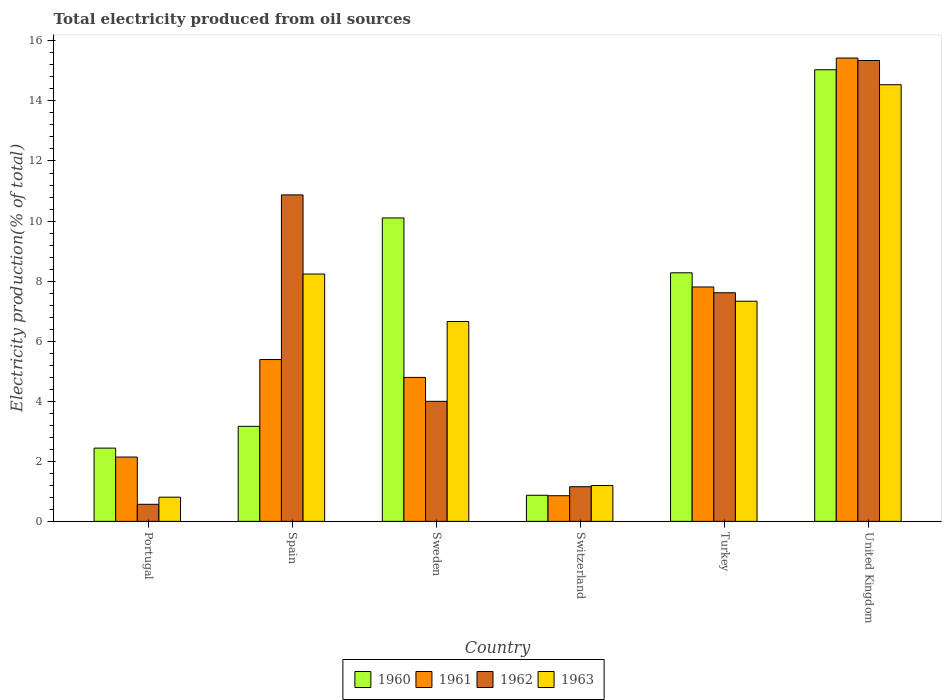How many groups of bars are there?
Offer a terse response. 6. How many bars are there on the 2nd tick from the left?
Offer a terse response. 4. What is the label of the 4th group of bars from the left?
Provide a short and direct response. Switzerland. What is the total electricity produced in 1963 in Turkey?
Provide a succinct answer. 7.33. Across all countries, what is the maximum total electricity produced in 1963?
Make the answer very short. 14.54. Across all countries, what is the minimum total electricity produced in 1960?
Ensure brevity in your answer.  0.87. In which country was the total electricity produced in 1961 maximum?
Your response must be concise. United Kingdom. In which country was the total electricity produced in 1961 minimum?
Make the answer very short. Switzerland. What is the total total electricity produced in 1962 in the graph?
Give a very brief answer. 39.55. What is the difference between the total electricity produced in 1961 in Portugal and that in Sweden?
Your response must be concise. -2.65. What is the difference between the total electricity produced in 1961 in Sweden and the total electricity produced in 1960 in Switzerland?
Your response must be concise. 3.92. What is the average total electricity produced in 1963 per country?
Provide a short and direct response. 6.46. What is the difference between the total electricity produced of/in 1960 and total electricity produced of/in 1963 in United Kingdom?
Ensure brevity in your answer.  0.5. What is the ratio of the total electricity produced in 1963 in Turkey to that in United Kingdom?
Offer a terse response. 0.5. Is the total electricity produced in 1963 in Spain less than that in Turkey?
Offer a very short reply. No. What is the difference between the highest and the second highest total electricity produced in 1962?
Your answer should be compact. 3.26. What is the difference between the highest and the lowest total electricity produced in 1961?
Provide a short and direct response. 14.57. Is it the case that in every country, the sum of the total electricity produced in 1963 and total electricity produced in 1962 is greater than the sum of total electricity produced in 1960 and total electricity produced in 1961?
Ensure brevity in your answer.  No. What does the 3rd bar from the right in Switzerland represents?
Make the answer very short. 1961. Is it the case that in every country, the sum of the total electricity produced in 1960 and total electricity produced in 1962 is greater than the total electricity produced in 1961?
Provide a short and direct response. Yes. How many bars are there?
Offer a terse response. 24. How many countries are there in the graph?
Your answer should be very brief. 6. What is the difference between two consecutive major ticks on the Y-axis?
Provide a short and direct response. 2. Are the values on the major ticks of Y-axis written in scientific E-notation?
Give a very brief answer. No. Does the graph contain any zero values?
Your answer should be very brief. No. Where does the legend appear in the graph?
Provide a succinct answer. Bottom center. How are the legend labels stacked?
Keep it short and to the point. Horizontal. What is the title of the graph?
Your response must be concise. Total electricity produced from oil sources. What is the label or title of the X-axis?
Provide a succinct answer. Country. What is the label or title of the Y-axis?
Your response must be concise. Electricity production(% of total). What is the Electricity production(% of total) of 1960 in Portugal?
Give a very brief answer. 2.44. What is the Electricity production(% of total) of 1961 in Portugal?
Provide a short and direct response. 2.14. What is the Electricity production(% of total) in 1962 in Portugal?
Give a very brief answer. 0.57. What is the Electricity production(% of total) in 1963 in Portugal?
Your answer should be compact. 0.81. What is the Electricity production(% of total) in 1960 in Spain?
Make the answer very short. 3.16. What is the Electricity production(% of total) in 1961 in Spain?
Your answer should be compact. 5.39. What is the Electricity production(% of total) of 1962 in Spain?
Give a very brief answer. 10.87. What is the Electricity production(% of total) in 1963 in Spain?
Give a very brief answer. 8.24. What is the Electricity production(% of total) of 1960 in Sweden?
Provide a succinct answer. 10.1. What is the Electricity production(% of total) of 1961 in Sweden?
Your response must be concise. 4.79. What is the Electricity production(% of total) of 1962 in Sweden?
Ensure brevity in your answer.  4. What is the Electricity production(% of total) in 1963 in Sweden?
Provide a succinct answer. 6.66. What is the Electricity production(% of total) in 1960 in Switzerland?
Give a very brief answer. 0.87. What is the Electricity production(% of total) of 1961 in Switzerland?
Give a very brief answer. 0.85. What is the Electricity production(% of total) of 1962 in Switzerland?
Give a very brief answer. 1.15. What is the Electricity production(% of total) of 1963 in Switzerland?
Your response must be concise. 1.19. What is the Electricity production(% of total) in 1960 in Turkey?
Your answer should be compact. 8.28. What is the Electricity production(% of total) of 1961 in Turkey?
Ensure brevity in your answer.  7.8. What is the Electricity production(% of total) of 1962 in Turkey?
Give a very brief answer. 7.61. What is the Electricity production(% of total) of 1963 in Turkey?
Offer a terse response. 7.33. What is the Electricity production(% of total) in 1960 in United Kingdom?
Your answer should be very brief. 15.04. What is the Electricity production(% of total) of 1961 in United Kingdom?
Provide a succinct answer. 15.43. What is the Electricity production(% of total) in 1962 in United Kingdom?
Provide a succinct answer. 15.35. What is the Electricity production(% of total) of 1963 in United Kingdom?
Provide a succinct answer. 14.54. Across all countries, what is the maximum Electricity production(% of total) of 1960?
Provide a short and direct response. 15.04. Across all countries, what is the maximum Electricity production(% of total) in 1961?
Provide a short and direct response. 15.43. Across all countries, what is the maximum Electricity production(% of total) in 1962?
Your answer should be compact. 15.35. Across all countries, what is the maximum Electricity production(% of total) in 1963?
Ensure brevity in your answer.  14.54. Across all countries, what is the minimum Electricity production(% of total) in 1960?
Provide a short and direct response. 0.87. Across all countries, what is the minimum Electricity production(% of total) of 1961?
Your answer should be very brief. 0.85. Across all countries, what is the minimum Electricity production(% of total) in 1962?
Your response must be concise. 0.57. Across all countries, what is the minimum Electricity production(% of total) in 1963?
Provide a short and direct response. 0.81. What is the total Electricity production(% of total) of 1960 in the graph?
Ensure brevity in your answer.  39.89. What is the total Electricity production(% of total) of 1961 in the graph?
Give a very brief answer. 36.41. What is the total Electricity production(% of total) of 1962 in the graph?
Offer a very short reply. 39.55. What is the total Electricity production(% of total) of 1963 in the graph?
Give a very brief answer. 38.76. What is the difference between the Electricity production(% of total) of 1960 in Portugal and that in Spain?
Ensure brevity in your answer.  -0.72. What is the difference between the Electricity production(% of total) in 1961 in Portugal and that in Spain?
Offer a terse response. -3.25. What is the difference between the Electricity production(% of total) in 1962 in Portugal and that in Spain?
Provide a succinct answer. -10.3. What is the difference between the Electricity production(% of total) in 1963 in Portugal and that in Spain?
Your answer should be compact. -7.43. What is the difference between the Electricity production(% of total) in 1960 in Portugal and that in Sweden?
Your response must be concise. -7.66. What is the difference between the Electricity production(% of total) of 1961 in Portugal and that in Sweden?
Ensure brevity in your answer.  -2.65. What is the difference between the Electricity production(% of total) in 1962 in Portugal and that in Sweden?
Your answer should be very brief. -3.43. What is the difference between the Electricity production(% of total) in 1963 in Portugal and that in Sweden?
Your answer should be very brief. -5.85. What is the difference between the Electricity production(% of total) of 1960 in Portugal and that in Switzerland?
Your answer should be very brief. 1.57. What is the difference between the Electricity production(% of total) in 1961 in Portugal and that in Switzerland?
Your response must be concise. 1.29. What is the difference between the Electricity production(% of total) in 1962 in Portugal and that in Switzerland?
Your response must be concise. -0.59. What is the difference between the Electricity production(% of total) of 1963 in Portugal and that in Switzerland?
Your answer should be very brief. -0.39. What is the difference between the Electricity production(% of total) in 1960 in Portugal and that in Turkey?
Keep it short and to the point. -5.84. What is the difference between the Electricity production(% of total) in 1961 in Portugal and that in Turkey?
Keep it short and to the point. -5.66. What is the difference between the Electricity production(% of total) of 1962 in Portugal and that in Turkey?
Give a very brief answer. -7.04. What is the difference between the Electricity production(% of total) in 1963 in Portugal and that in Turkey?
Provide a succinct answer. -6.53. What is the difference between the Electricity production(% of total) of 1960 in Portugal and that in United Kingdom?
Offer a very short reply. -12.6. What is the difference between the Electricity production(% of total) in 1961 in Portugal and that in United Kingdom?
Provide a short and direct response. -13.29. What is the difference between the Electricity production(% of total) of 1962 in Portugal and that in United Kingdom?
Ensure brevity in your answer.  -14.78. What is the difference between the Electricity production(% of total) of 1963 in Portugal and that in United Kingdom?
Keep it short and to the point. -13.74. What is the difference between the Electricity production(% of total) in 1960 in Spain and that in Sweden?
Ensure brevity in your answer.  -6.94. What is the difference between the Electricity production(% of total) of 1961 in Spain and that in Sweden?
Your answer should be very brief. 0.6. What is the difference between the Electricity production(% of total) in 1962 in Spain and that in Sweden?
Provide a short and direct response. 6.87. What is the difference between the Electricity production(% of total) in 1963 in Spain and that in Sweden?
Your response must be concise. 1.58. What is the difference between the Electricity production(% of total) of 1960 in Spain and that in Switzerland?
Your response must be concise. 2.29. What is the difference between the Electricity production(% of total) of 1961 in Spain and that in Switzerland?
Give a very brief answer. 4.53. What is the difference between the Electricity production(% of total) of 1962 in Spain and that in Switzerland?
Your answer should be compact. 9.72. What is the difference between the Electricity production(% of total) of 1963 in Spain and that in Switzerland?
Your answer should be compact. 7.04. What is the difference between the Electricity production(% of total) of 1960 in Spain and that in Turkey?
Provide a short and direct response. -5.11. What is the difference between the Electricity production(% of total) of 1961 in Spain and that in Turkey?
Offer a terse response. -2.42. What is the difference between the Electricity production(% of total) in 1962 in Spain and that in Turkey?
Your answer should be very brief. 3.26. What is the difference between the Electricity production(% of total) of 1963 in Spain and that in Turkey?
Give a very brief answer. 0.91. What is the difference between the Electricity production(% of total) of 1960 in Spain and that in United Kingdom?
Keep it short and to the point. -11.87. What is the difference between the Electricity production(% of total) in 1961 in Spain and that in United Kingdom?
Provide a short and direct response. -10.04. What is the difference between the Electricity production(% of total) of 1962 in Spain and that in United Kingdom?
Provide a succinct answer. -4.48. What is the difference between the Electricity production(% of total) of 1963 in Spain and that in United Kingdom?
Your answer should be compact. -6.3. What is the difference between the Electricity production(% of total) in 1960 in Sweden and that in Switzerland?
Your answer should be compact. 9.23. What is the difference between the Electricity production(% of total) of 1961 in Sweden and that in Switzerland?
Ensure brevity in your answer.  3.94. What is the difference between the Electricity production(% of total) in 1962 in Sweden and that in Switzerland?
Offer a terse response. 2.84. What is the difference between the Electricity production(% of total) of 1963 in Sweden and that in Switzerland?
Give a very brief answer. 5.46. What is the difference between the Electricity production(% of total) in 1960 in Sweden and that in Turkey?
Give a very brief answer. 1.83. What is the difference between the Electricity production(% of total) in 1961 in Sweden and that in Turkey?
Make the answer very short. -3.01. What is the difference between the Electricity production(% of total) in 1962 in Sweden and that in Turkey?
Ensure brevity in your answer.  -3.61. What is the difference between the Electricity production(% of total) of 1963 in Sweden and that in Turkey?
Provide a short and direct response. -0.68. What is the difference between the Electricity production(% of total) of 1960 in Sweden and that in United Kingdom?
Offer a terse response. -4.93. What is the difference between the Electricity production(% of total) of 1961 in Sweden and that in United Kingdom?
Your answer should be very brief. -10.64. What is the difference between the Electricity production(% of total) in 1962 in Sweden and that in United Kingdom?
Your answer should be very brief. -11.35. What is the difference between the Electricity production(% of total) in 1963 in Sweden and that in United Kingdom?
Make the answer very short. -7.89. What is the difference between the Electricity production(% of total) of 1960 in Switzerland and that in Turkey?
Offer a terse response. -7.41. What is the difference between the Electricity production(% of total) in 1961 in Switzerland and that in Turkey?
Give a very brief answer. -6.95. What is the difference between the Electricity production(% of total) in 1962 in Switzerland and that in Turkey?
Make the answer very short. -6.46. What is the difference between the Electricity production(% of total) of 1963 in Switzerland and that in Turkey?
Your response must be concise. -6.14. What is the difference between the Electricity production(% of total) of 1960 in Switzerland and that in United Kingdom?
Offer a very short reply. -14.17. What is the difference between the Electricity production(% of total) in 1961 in Switzerland and that in United Kingdom?
Offer a terse response. -14.57. What is the difference between the Electricity production(% of total) of 1962 in Switzerland and that in United Kingdom?
Offer a very short reply. -14.19. What is the difference between the Electricity production(% of total) of 1963 in Switzerland and that in United Kingdom?
Your answer should be compact. -13.35. What is the difference between the Electricity production(% of total) in 1960 in Turkey and that in United Kingdom?
Your response must be concise. -6.76. What is the difference between the Electricity production(% of total) of 1961 in Turkey and that in United Kingdom?
Provide a succinct answer. -7.62. What is the difference between the Electricity production(% of total) in 1962 in Turkey and that in United Kingdom?
Offer a terse response. -7.73. What is the difference between the Electricity production(% of total) of 1963 in Turkey and that in United Kingdom?
Give a very brief answer. -7.21. What is the difference between the Electricity production(% of total) in 1960 in Portugal and the Electricity production(% of total) in 1961 in Spain?
Offer a terse response. -2.95. What is the difference between the Electricity production(% of total) in 1960 in Portugal and the Electricity production(% of total) in 1962 in Spain?
Keep it short and to the point. -8.43. What is the difference between the Electricity production(% of total) in 1960 in Portugal and the Electricity production(% of total) in 1963 in Spain?
Provide a succinct answer. -5.8. What is the difference between the Electricity production(% of total) in 1961 in Portugal and the Electricity production(% of total) in 1962 in Spain?
Make the answer very short. -8.73. What is the difference between the Electricity production(% of total) of 1961 in Portugal and the Electricity production(% of total) of 1963 in Spain?
Provide a short and direct response. -6.09. What is the difference between the Electricity production(% of total) in 1962 in Portugal and the Electricity production(% of total) in 1963 in Spain?
Provide a succinct answer. -7.67. What is the difference between the Electricity production(% of total) in 1960 in Portugal and the Electricity production(% of total) in 1961 in Sweden?
Keep it short and to the point. -2.35. What is the difference between the Electricity production(% of total) in 1960 in Portugal and the Electricity production(% of total) in 1962 in Sweden?
Your answer should be very brief. -1.56. What is the difference between the Electricity production(% of total) of 1960 in Portugal and the Electricity production(% of total) of 1963 in Sweden?
Keep it short and to the point. -4.22. What is the difference between the Electricity production(% of total) of 1961 in Portugal and the Electricity production(% of total) of 1962 in Sweden?
Provide a succinct answer. -1.86. What is the difference between the Electricity production(% of total) in 1961 in Portugal and the Electricity production(% of total) in 1963 in Sweden?
Offer a terse response. -4.51. What is the difference between the Electricity production(% of total) of 1962 in Portugal and the Electricity production(% of total) of 1963 in Sweden?
Your answer should be very brief. -6.09. What is the difference between the Electricity production(% of total) of 1960 in Portugal and the Electricity production(% of total) of 1961 in Switzerland?
Your answer should be compact. 1.59. What is the difference between the Electricity production(% of total) of 1960 in Portugal and the Electricity production(% of total) of 1962 in Switzerland?
Provide a succinct answer. 1.29. What is the difference between the Electricity production(% of total) of 1960 in Portugal and the Electricity production(% of total) of 1963 in Switzerland?
Your answer should be very brief. 1.25. What is the difference between the Electricity production(% of total) of 1961 in Portugal and the Electricity production(% of total) of 1962 in Switzerland?
Your response must be concise. 0.99. What is the difference between the Electricity production(% of total) of 1961 in Portugal and the Electricity production(% of total) of 1963 in Switzerland?
Keep it short and to the point. 0.95. What is the difference between the Electricity production(% of total) in 1962 in Portugal and the Electricity production(% of total) in 1963 in Switzerland?
Your answer should be very brief. -0.63. What is the difference between the Electricity production(% of total) in 1960 in Portugal and the Electricity production(% of total) in 1961 in Turkey?
Your answer should be very brief. -5.36. What is the difference between the Electricity production(% of total) in 1960 in Portugal and the Electricity production(% of total) in 1962 in Turkey?
Your answer should be very brief. -5.17. What is the difference between the Electricity production(% of total) of 1960 in Portugal and the Electricity production(% of total) of 1963 in Turkey?
Keep it short and to the point. -4.89. What is the difference between the Electricity production(% of total) of 1961 in Portugal and the Electricity production(% of total) of 1962 in Turkey?
Offer a terse response. -5.47. What is the difference between the Electricity production(% of total) in 1961 in Portugal and the Electricity production(% of total) in 1963 in Turkey?
Give a very brief answer. -5.19. What is the difference between the Electricity production(% of total) in 1962 in Portugal and the Electricity production(% of total) in 1963 in Turkey?
Your response must be concise. -6.76. What is the difference between the Electricity production(% of total) in 1960 in Portugal and the Electricity production(% of total) in 1961 in United Kingdom?
Provide a succinct answer. -12.99. What is the difference between the Electricity production(% of total) in 1960 in Portugal and the Electricity production(% of total) in 1962 in United Kingdom?
Your answer should be compact. -12.91. What is the difference between the Electricity production(% of total) of 1960 in Portugal and the Electricity production(% of total) of 1963 in United Kingdom?
Make the answer very short. -12.1. What is the difference between the Electricity production(% of total) in 1961 in Portugal and the Electricity production(% of total) in 1962 in United Kingdom?
Your answer should be very brief. -13.2. What is the difference between the Electricity production(% of total) in 1961 in Portugal and the Electricity production(% of total) in 1963 in United Kingdom?
Give a very brief answer. -12.4. What is the difference between the Electricity production(% of total) in 1962 in Portugal and the Electricity production(% of total) in 1963 in United Kingdom?
Make the answer very short. -13.97. What is the difference between the Electricity production(% of total) in 1960 in Spain and the Electricity production(% of total) in 1961 in Sweden?
Provide a short and direct response. -1.63. What is the difference between the Electricity production(% of total) in 1960 in Spain and the Electricity production(% of total) in 1963 in Sweden?
Keep it short and to the point. -3.49. What is the difference between the Electricity production(% of total) in 1961 in Spain and the Electricity production(% of total) in 1962 in Sweden?
Your answer should be very brief. 1.39. What is the difference between the Electricity production(% of total) of 1961 in Spain and the Electricity production(% of total) of 1963 in Sweden?
Your answer should be compact. -1.27. What is the difference between the Electricity production(% of total) of 1962 in Spain and the Electricity production(% of total) of 1963 in Sweden?
Make the answer very short. 4.22. What is the difference between the Electricity production(% of total) of 1960 in Spain and the Electricity production(% of total) of 1961 in Switzerland?
Offer a very short reply. 2.31. What is the difference between the Electricity production(% of total) of 1960 in Spain and the Electricity production(% of total) of 1962 in Switzerland?
Ensure brevity in your answer.  2.01. What is the difference between the Electricity production(% of total) in 1960 in Spain and the Electricity production(% of total) in 1963 in Switzerland?
Make the answer very short. 1.97. What is the difference between the Electricity production(% of total) of 1961 in Spain and the Electricity production(% of total) of 1962 in Switzerland?
Provide a short and direct response. 4.24. What is the difference between the Electricity production(% of total) in 1961 in Spain and the Electricity production(% of total) in 1963 in Switzerland?
Provide a succinct answer. 4.2. What is the difference between the Electricity production(% of total) in 1962 in Spain and the Electricity production(% of total) in 1963 in Switzerland?
Give a very brief answer. 9.68. What is the difference between the Electricity production(% of total) of 1960 in Spain and the Electricity production(% of total) of 1961 in Turkey?
Your answer should be compact. -4.64. What is the difference between the Electricity production(% of total) of 1960 in Spain and the Electricity production(% of total) of 1962 in Turkey?
Provide a succinct answer. -4.45. What is the difference between the Electricity production(% of total) in 1960 in Spain and the Electricity production(% of total) in 1963 in Turkey?
Offer a terse response. -4.17. What is the difference between the Electricity production(% of total) in 1961 in Spain and the Electricity production(% of total) in 1962 in Turkey?
Provide a succinct answer. -2.22. What is the difference between the Electricity production(% of total) in 1961 in Spain and the Electricity production(% of total) in 1963 in Turkey?
Provide a succinct answer. -1.94. What is the difference between the Electricity production(% of total) of 1962 in Spain and the Electricity production(% of total) of 1963 in Turkey?
Make the answer very short. 3.54. What is the difference between the Electricity production(% of total) in 1960 in Spain and the Electricity production(% of total) in 1961 in United Kingdom?
Give a very brief answer. -12.26. What is the difference between the Electricity production(% of total) in 1960 in Spain and the Electricity production(% of total) in 1962 in United Kingdom?
Offer a terse response. -12.18. What is the difference between the Electricity production(% of total) in 1960 in Spain and the Electricity production(% of total) in 1963 in United Kingdom?
Provide a short and direct response. -11.38. What is the difference between the Electricity production(% of total) of 1961 in Spain and the Electricity production(% of total) of 1962 in United Kingdom?
Provide a short and direct response. -9.96. What is the difference between the Electricity production(% of total) in 1961 in Spain and the Electricity production(% of total) in 1963 in United Kingdom?
Provide a succinct answer. -9.15. What is the difference between the Electricity production(% of total) of 1962 in Spain and the Electricity production(% of total) of 1963 in United Kingdom?
Offer a very short reply. -3.67. What is the difference between the Electricity production(% of total) of 1960 in Sweden and the Electricity production(% of total) of 1961 in Switzerland?
Offer a very short reply. 9.25. What is the difference between the Electricity production(% of total) of 1960 in Sweden and the Electricity production(% of total) of 1962 in Switzerland?
Your answer should be compact. 8.95. What is the difference between the Electricity production(% of total) of 1960 in Sweden and the Electricity production(% of total) of 1963 in Switzerland?
Your answer should be compact. 8.91. What is the difference between the Electricity production(% of total) in 1961 in Sweden and the Electricity production(% of total) in 1962 in Switzerland?
Provide a succinct answer. 3.64. What is the difference between the Electricity production(% of total) in 1961 in Sweden and the Electricity production(% of total) in 1963 in Switzerland?
Provide a succinct answer. 3.6. What is the difference between the Electricity production(% of total) in 1962 in Sweden and the Electricity production(% of total) in 1963 in Switzerland?
Provide a succinct answer. 2.8. What is the difference between the Electricity production(% of total) of 1960 in Sweden and the Electricity production(% of total) of 1961 in Turkey?
Ensure brevity in your answer.  2.3. What is the difference between the Electricity production(% of total) of 1960 in Sweden and the Electricity production(% of total) of 1962 in Turkey?
Ensure brevity in your answer.  2.49. What is the difference between the Electricity production(% of total) in 1960 in Sweden and the Electricity production(% of total) in 1963 in Turkey?
Make the answer very short. 2.77. What is the difference between the Electricity production(% of total) in 1961 in Sweden and the Electricity production(% of total) in 1962 in Turkey?
Offer a terse response. -2.82. What is the difference between the Electricity production(% of total) of 1961 in Sweden and the Electricity production(% of total) of 1963 in Turkey?
Your answer should be very brief. -2.54. What is the difference between the Electricity production(% of total) of 1962 in Sweden and the Electricity production(% of total) of 1963 in Turkey?
Give a very brief answer. -3.33. What is the difference between the Electricity production(% of total) in 1960 in Sweden and the Electricity production(% of total) in 1961 in United Kingdom?
Your response must be concise. -5.32. What is the difference between the Electricity production(% of total) in 1960 in Sweden and the Electricity production(% of total) in 1962 in United Kingdom?
Provide a short and direct response. -5.24. What is the difference between the Electricity production(% of total) of 1960 in Sweden and the Electricity production(% of total) of 1963 in United Kingdom?
Offer a terse response. -4.44. What is the difference between the Electricity production(% of total) of 1961 in Sweden and the Electricity production(% of total) of 1962 in United Kingdom?
Keep it short and to the point. -10.55. What is the difference between the Electricity production(% of total) of 1961 in Sweden and the Electricity production(% of total) of 1963 in United Kingdom?
Provide a short and direct response. -9.75. What is the difference between the Electricity production(% of total) of 1962 in Sweden and the Electricity production(% of total) of 1963 in United Kingdom?
Provide a succinct answer. -10.54. What is the difference between the Electricity production(% of total) in 1960 in Switzerland and the Electricity production(% of total) in 1961 in Turkey?
Provide a succinct answer. -6.94. What is the difference between the Electricity production(% of total) of 1960 in Switzerland and the Electricity production(% of total) of 1962 in Turkey?
Your response must be concise. -6.74. What is the difference between the Electricity production(% of total) in 1960 in Switzerland and the Electricity production(% of total) in 1963 in Turkey?
Offer a terse response. -6.46. What is the difference between the Electricity production(% of total) in 1961 in Switzerland and the Electricity production(% of total) in 1962 in Turkey?
Give a very brief answer. -6.76. What is the difference between the Electricity production(% of total) in 1961 in Switzerland and the Electricity production(% of total) in 1963 in Turkey?
Offer a terse response. -6.48. What is the difference between the Electricity production(% of total) of 1962 in Switzerland and the Electricity production(% of total) of 1963 in Turkey?
Your response must be concise. -6.18. What is the difference between the Electricity production(% of total) in 1960 in Switzerland and the Electricity production(% of total) in 1961 in United Kingdom?
Ensure brevity in your answer.  -14.56. What is the difference between the Electricity production(% of total) in 1960 in Switzerland and the Electricity production(% of total) in 1962 in United Kingdom?
Your answer should be compact. -14.48. What is the difference between the Electricity production(% of total) of 1960 in Switzerland and the Electricity production(% of total) of 1963 in United Kingdom?
Provide a succinct answer. -13.67. What is the difference between the Electricity production(% of total) of 1961 in Switzerland and the Electricity production(% of total) of 1962 in United Kingdom?
Keep it short and to the point. -14.49. What is the difference between the Electricity production(% of total) in 1961 in Switzerland and the Electricity production(% of total) in 1963 in United Kingdom?
Give a very brief answer. -13.69. What is the difference between the Electricity production(% of total) in 1962 in Switzerland and the Electricity production(% of total) in 1963 in United Kingdom?
Your answer should be very brief. -13.39. What is the difference between the Electricity production(% of total) of 1960 in Turkey and the Electricity production(% of total) of 1961 in United Kingdom?
Your response must be concise. -7.15. What is the difference between the Electricity production(% of total) of 1960 in Turkey and the Electricity production(% of total) of 1962 in United Kingdom?
Keep it short and to the point. -7.07. What is the difference between the Electricity production(% of total) in 1960 in Turkey and the Electricity production(% of total) in 1963 in United Kingdom?
Your response must be concise. -6.26. What is the difference between the Electricity production(% of total) in 1961 in Turkey and the Electricity production(% of total) in 1962 in United Kingdom?
Your response must be concise. -7.54. What is the difference between the Electricity production(% of total) of 1961 in Turkey and the Electricity production(% of total) of 1963 in United Kingdom?
Make the answer very short. -6.74. What is the difference between the Electricity production(% of total) of 1962 in Turkey and the Electricity production(% of total) of 1963 in United Kingdom?
Your answer should be compact. -6.93. What is the average Electricity production(% of total) of 1960 per country?
Give a very brief answer. 6.65. What is the average Electricity production(% of total) in 1961 per country?
Your answer should be very brief. 6.07. What is the average Electricity production(% of total) in 1962 per country?
Your answer should be very brief. 6.59. What is the average Electricity production(% of total) of 1963 per country?
Offer a very short reply. 6.46. What is the difference between the Electricity production(% of total) in 1960 and Electricity production(% of total) in 1961 in Portugal?
Make the answer very short. 0.3. What is the difference between the Electricity production(% of total) of 1960 and Electricity production(% of total) of 1962 in Portugal?
Give a very brief answer. 1.87. What is the difference between the Electricity production(% of total) in 1960 and Electricity production(% of total) in 1963 in Portugal?
Offer a very short reply. 1.63. What is the difference between the Electricity production(% of total) of 1961 and Electricity production(% of total) of 1962 in Portugal?
Keep it short and to the point. 1.57. What is the difference between the Electricity production(% of total) in 1961 and Electricity production(% of total) in 1963 in Portugal?
Your response must be concise. 1.34. What is the difference between the Electricity production(% of total) of 1962 and Electricity production(% of total) of 1963 in Portugal?
Keep it short and to the point. -0.24. What is the difference between the Electricity production(% of total) in 1960 and Electricity production(% of total) in 1961 in Spain?
Your response must be concise. -2.22. What is the difference between the Electricity production(% of total) in 1960 and Electricity production(% of total) in 1962 in Spain?
Provide a short and direct response. -7.71. What is the difference between the Electricity production(% of total) in 1960 and Electricity production(% of total) in 1963 in Spain?
Your answer should be very brief. -5.07. What is the difference between the Electricity production(% of total) of 1961 and Electricity production(% of total) of 1962 in Spain?
Ensure brevity in your answer.  -5.48. What is the difference between the Electricity production(% of total) in 1961 and Electricity production(% of total) in 1963 in Spain?
Offer a very short reply. -2.85. What is the difference between the Electricity production(% of total) of 1962 and Electricity production(% of total) of 1963 in Spain?
Your answer should be very brief. 2.63. What is the difference between the Electricity production(% of total) in 1960 and Electricity production(% of total) in 1961 in Sweden?
Offer a terse response. 5.31. What is the difference between the Electricity production(% of total) of 1960 and Electricity production(% of total) of 1962 in Sweden?
Offer a very short reply. 6.11. What is the difference between the Electricity production(% of total) in 1960 and Electricity production(% of total) in 1963 in Sweden?
Ensure brevity in your answer.  3.45. What is the difference between the Electricity production(% of total) in 1961 and Electricity production(% of total) in 1962 in Sweden?
Your answer should be very brief. 0.8. What is the difference between the Electricity production(% of total) of 1961 and Electricity production(% of total) of 1963 in Sweden?
Your answer should be compact. -1.86. What is the difference between the Electricity production(% of total) of 1962 and Electricity production(% of total) of 1963 in Sweden?
Your response must be concise. -2.66. What is the difference between the Electricity production(% of total) in 1960 and Electricity production(% of total) in 1961 in Switzerland?
Provide a short and direct response. 0.02. What is the difference between the Electricity production(% of total) of 1960 and Electricity production(% of total) of 1962 in Switzerland?
Your answer should be very brief. -0.28. What is the difference between the Electricity production(% of total) of 1960 and Electricity production(% of total) of 1963 in Switzerland?
Offer a very short reply. -0.32. What is the difference between the Electricity production(% of total) of 1961 and Electricity production(% of total) of 1962 in Switzerland?
Give a very brief answer. -0.3. What is the difference between the Electricity production(% of total) of 1961 and Electricity production(% of total) of 1963 in Switzerland?
Your answer should be compact. -0.34. What is the difference between the Electricity production(% of total) of 1962 and Electricity production(% of total) of 1963 in Switzerland?
Provide a succinct answer. -0.04. What is the difference between the Electricity production(% of total) in 1960 and Electricity production(% of total) in 1961 in Turkey?
Ensure brevity in your answer.  0.47. What is the difference between the Electricity production(% of total) in 1960 and Electricity production(% of total) in 1962 in Turkey?
Ensure brevity in your answer.  0.66. What is the difference between the Electricity production(% of total) in 1960 and Electricity production(% of total) in 1963 in Turkey?
Offer a terse response. 0.95. What is the difference between the Electricity production(% of total) of 1961 and Electricity production(% of total) of 1962 in Turkey?
Offer a terse response. 0.19. What is the difference between the Electricity production(% of total) of 1961 and Electricity production(% of total) of 1963 in Turkey?
Your response must be concise. 0.47. What is the difference between the Electricity production(% of total) in 1962 and Electricity production(% of total) in 1963 in Turkey?
Provide a succinct answer. 0.28. What is the difference between the Electricity production(% of total) in 1960 and Electricity production(% of total) in 1961 in United Kingdom?
Your response must be concise. -0.39. What is the difference between the Electricity production(% of total) of 1960 and Electricity production(% of total) of 1962 in United Kingdom?
Offer a terse response. -0.31. What is the difference between the Electricity production(% of total) in 1960 and Electricity production(% of total) in 1963 in United Kingdom?
Keep it short and to the point. 0.5. What is the difference between the Electricity production(% of total) in 1961 and Electricity production(% of total) in 1962 in United Kingdom?
Keep it short and to the point. 0.08. What is the difference between the Electricity production(% of total) of 1961 and Electricity production(% of total) of 1963 in United Kingdom?
Ensure brevity in your answer.  0.89. What is the difference between the Electricity production(% of total) in 1962 and Electricity production(% of total) in 1963 in United Kingdom?
Offer a very short reply. 0.81. What is the ratio of the Electricity production(% of total) in 1960 in Portugal to that in Spain?
Your answer should be compact. 0.77. What is the ratio of the Electricity production(% of total) of 1961 in Portugal to that in Spain?
Make the answer very short. 0.4. What is the ratio of the Electricity production(% of total) of 1962 in Portugal to that in Spain?
Your response must be concise. 0.05. What is the ratio of the Electricity production(% of total) in 1963 in Portugal to that in Spain?
Give a very brief answer. 0.1. What is the ratio of the Electricity production(% of total) in 1960 in Portugal to that in Sweden?
Your response must be concise. 0.24. What is the ratio of the Electricity production(% of total) of 1961 in Portugal to that in Sweden?
Offer a very short reply. 0.45. What is the ratio of the Electricity production(% of total) in 1962 in Portugal to that in Sweden?
Provide a succinct answer. 0.14. What is the ratio of the Electricity production(% of total) of 1963 in Portugal to that in Sweden?
Make the answer very short. 0.12. What is the ratio of the Electricity production(% of total) of 1960 in Portugal to that in Switzerland?
Ensure brevity in your answer.  2.81. What is the ratio of the Electricity production(% of total) in 1961 in Portugal to that in Switzerland?
Your response must be concise. 2.51. What is the ratio of the Electricity production(% of total) in 1962 in Portugal to that in Switzerland?
Give a very brief answer. 0.49. What is the ratio of the Electricity production(% of total) of 1963 in Portugal to that in Switzerland?
Give a very brief answer. 0.67. What is the ratio of the Electricity production(% of total) in 1960 in Portugal to that in Turkey?
Keep it short and to the point. 0.29. What is the ratio of the Electricity production(% of total) of 1961 in Portugal to that in Turkey?
Offer a very short reply. 0.27. What is the ratio of the Electricity production(% of total) of 1962 in Portugal to that in Turkey?
Ensure brevity in your answer.  0.07. What is the ratio of the Electricity production(% of total) in 1963 in Portugal to that in Turkey?
Offer a terse response. 0.11. What is the ratio of the Electricity production(% of total) in 1960 in Portugal to that in United Kingdom?
Offer a very short reply. 0.16. What is the ratio of the Electricity production(% of total) of 1961 in Portugal to that in United Kingdom?
Keep it short and to the point. 0.14. What is the ratio of the Electricity production(% of total) in 1962 in Portugal to that in United Kingdom?
Make the answer very short. 0.04. What is the ratio of the Electricity production(% of total) of 1963 in Portugal to that in United Kingdom?
Your answer should be very brief. 0.06. What is the ratio of the Electricity production(% of total) of 1960 in Spain to that in Sweden?
Make the answer very short. 0.31. What is the ratio of the Electricity production(% of total) of 1961 in Spain to that in Sweden?
Keep it short and to the point. 1.12. What is the ratio of the Electricity production(% of total) in 1962 in Spain to that in Sweden?
Give a very brief answer. 2.72. What is the ratio of the Electricity production(% of total) in 1963 in Spain to that in Sweden?
Your answer should be very brief. 1.24. What is the ratio of the Electricity production(% of total) in 1960 in Spain to that in Switzerland?
Your answer should be compact. 3.64. What is the ratio of the Electricity production(% of total) in 1961 in Spain to that in Switzerland?
Give a very brief answer. 6.31. What is the ratio of the Electricity production(% of total) in 1962 in Spain to that in Switzerland?
Give a very brief answer. 9.43. What is the ratio of the Electricity production(% of total) in 1963 in Spain to that in Switzerland?
Ensure brevity in your answer.  6.9. What is the ratio of the Electricity production(% of total) of 1960 in Spain to that in Turkey?
Offer a very short reply. 0.38. What is the ratio of the Electricity production(% of total) of 1961 in Spain to that in Turkey?
Offer a terse response. 0.69. What is the ratio of the Electricity production(% of total) of 1962 in Spain to that in Turkey?
Offer a terse response. 1.43. What is the ratio of the Electricity production(% of total) of 1963 in Spain to that in Turkey?
Offer a very short reply. 1.12. What is the ratio of the Electricity production(% of total) in 1960 in Spain to that in United Kingdom?
Offer a very short reply. 0.21. What is the ratio of the Electricity production(% of total) in 1961 in Spain to that in United Kingdom?
Give a very brief answer. 0.35. What is the ratio of the Electricity production(% of total) of 1962 in Spain to that in United Kingdom?
Make the answer very short. 0.71. What is the ratio of the Electricity production(% of total) in 1963 in Spain to that in United Kingdom?
Offer a terse response. 0.57. What is the ratio of the Electricity production(% of total) in 1960 in Sweden to that in Switzerland?
Provide a short and direct response. 11.62. What is the ratio of the Electricity production(% of total) in 1961 in Sweden to that in Switzerland?
Make the answer very short. 5.62. What is the ratio of the Electricity production(% of total) in 1962 in Sweden to that in Switzerland?
Provide a short and direct response. 3.47. What is the ratio of the Electricity production(% of total) in 1963 in Sweden to that in Switzerland?
Keep it short and to the point. 5.58. What is the ratio of the Electricity production(% of total) of 1960 in Sweden to that in Turkey?
Offer a terse response. 1.22. What is the ratio of the Electricity production(% of total) of 1961 in Sweden to that in Turkey?
Your answer should be very brief. 0.61. What is the ratio of the Electricity production(% of total) of 1962 in Sweden to that in Turkey?
Offer a terse response. 0.53. What is the ratio of the Electricity production(% of total) of 1963 in Sweden to that in Turkey?
Offer a terse response. 0.91. What is the ratio of the Electricity production(% of total) of 1960 in Sweden to that in United Kingdom?
Offer a very short reply. 0.67. What is the ratio of the Electricity production(% of total) in 1961 in Sweden to that in United Kingdom?
Offer a very short reply. 0.31. What is the ratio of the Electricity production(% of total) in 1962 in Sweden to that in United Kingdom?
Make the answer very short. 0.26. What is the ratio of the Electricity production(% of total) in 1963 in Sweden to that in United Kingdom?
Provide a succinct answer. 0.46. What is the ratio of the Electricity production(% of total) in 1960 in Switzerland to that in Turkey?
Ensure brevity in your answer.  0.11. What is the ratio of the Electricity production(% of total) in 1961 in Switzerland to that in Turkey?
Give a very brief answer. 0.11. What is the ratio of the Electricity production(% of total) in 1962 in Switzerland to that in Turkey?
Give a very brief answer. 0.15. What is the ratio of the Electricity production(% of total) of 1963 in Switzerland to that in Turkey?
Your answer should be compact. 0.16. What is the ratio of the Electricity production(% of total) in 1960 in Switzerland to that in United Kingdom?
Provide a succinct answer. 0.06. What is the ratio of the Electricity production(% of total) of 1961 in Switzerland to that in United Kingdom?
Provide a short and direct response. 0.06. What is the ratio of the Electricity production(% of total) of 1962 in Switzerland to that in United Kingdom?
Offer a terse response. 0.08. What is the ratio of the Electricity production(% of total) in 1963 in Switzerland to that in United Kingdom?
Make the answer very short. 0.08. What is the ratio of the Electricity production(% of total) of 1960 in Turkey to that in United Kingdom?
Your answer should be compact. 0.55. What is the ratio of the Electricity production(% of total) of 1961 in Turkey to that in United Kingdom?
Your response must be concise. 0.51. What is the ratio of the Electricity production(% of total) in 1962 in Turkey to that in United Kingdom?
Give a very brief answer. 0.5. What is the ratio of the Electricity production(% of total) in 1963 in Turkey to that in United Kingdom?
Provide a succinct answer. 0.5. What is the difference between the highest and the second highest Electricity production(% of total) in 1960?
Keep it short and to the point. 4.93. What is the difference between the highest and the second highest Electricity production(% of total) of 1961?
Ensure brevity in your answer.  7.62. What is the difference between the highest and the second highest Electricity production(% of total) of 1962?
Offer a terse response. 4.48. What is the difference between the highest and the second highest Electricity production(% of total) of 1963?
Provide a short and direct response. 6.3. What is the difference between the highest and the lowest Electricity production(% of total) in 1960?
Give a very brief answer. 14.17. What is the difference between the highest and the lowest Electricity production(% of total) of 1961?
Your answer should be compact. 14.57. What is the difference between the highest and the lowest Electricity production(% of total) in 1962?
Your response must be concise. 14.78. What is the difference between the highest and the lowest Electricity production(% of total) of 1963?
Ensure brevity in your answer.  13.74. 